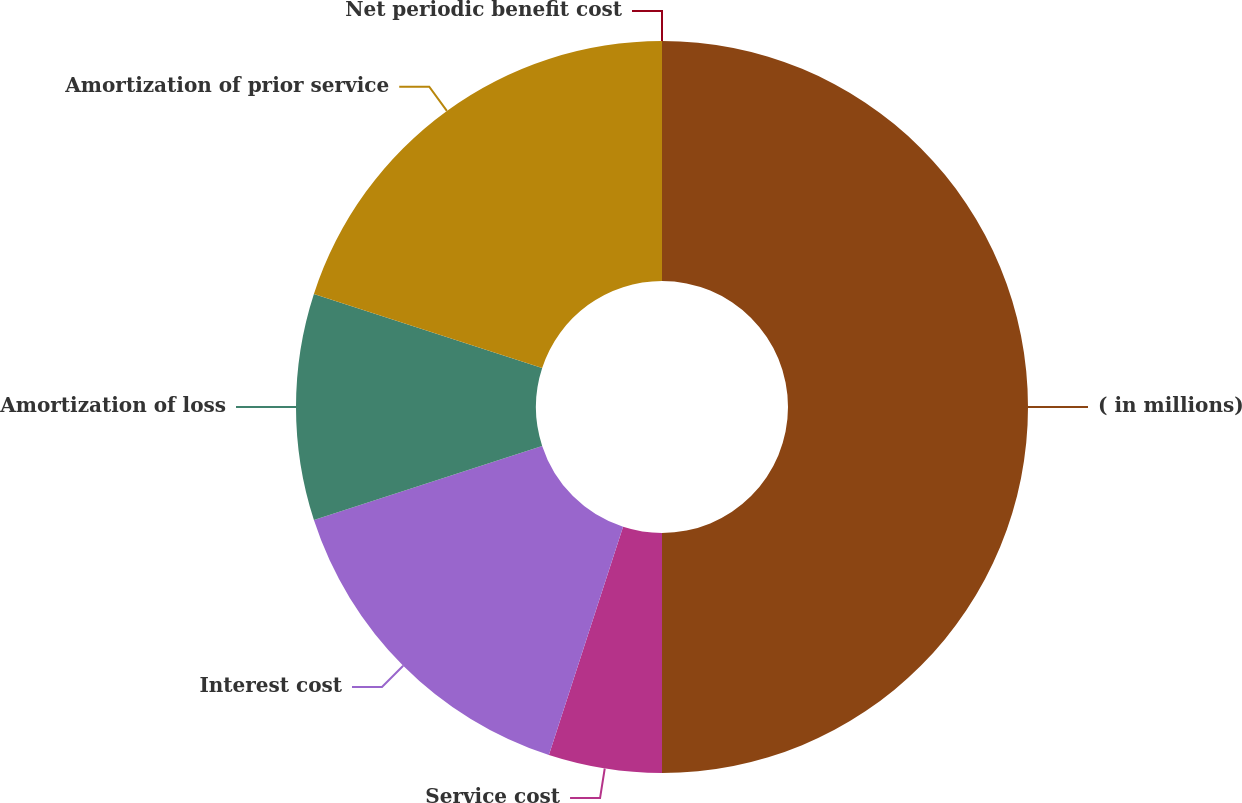Convert chart. <chart><loc_0><loc_0><loc_500><loc_500><pie_chart><fcel>( in millions)<fcel>Service cost<fcel>Interest cost<fcel>Amortization of loss<fcel>Amortization of prior service<fcel>Net periodic benefit cost<nl><fcel>50.0%<fcel>5.0%<fcel>15.0%<fcel>10.0%<fcel>20.0%<fcel>0.0%<nl></chart> 